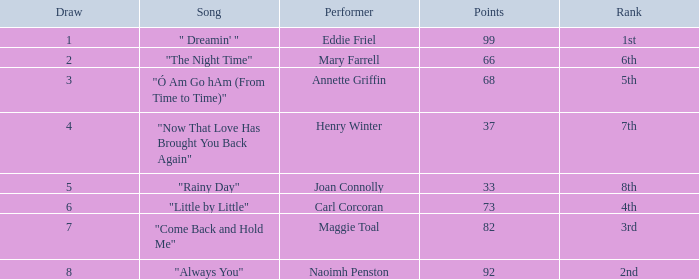What is the lowest value when the ranking is first? 99.0. 